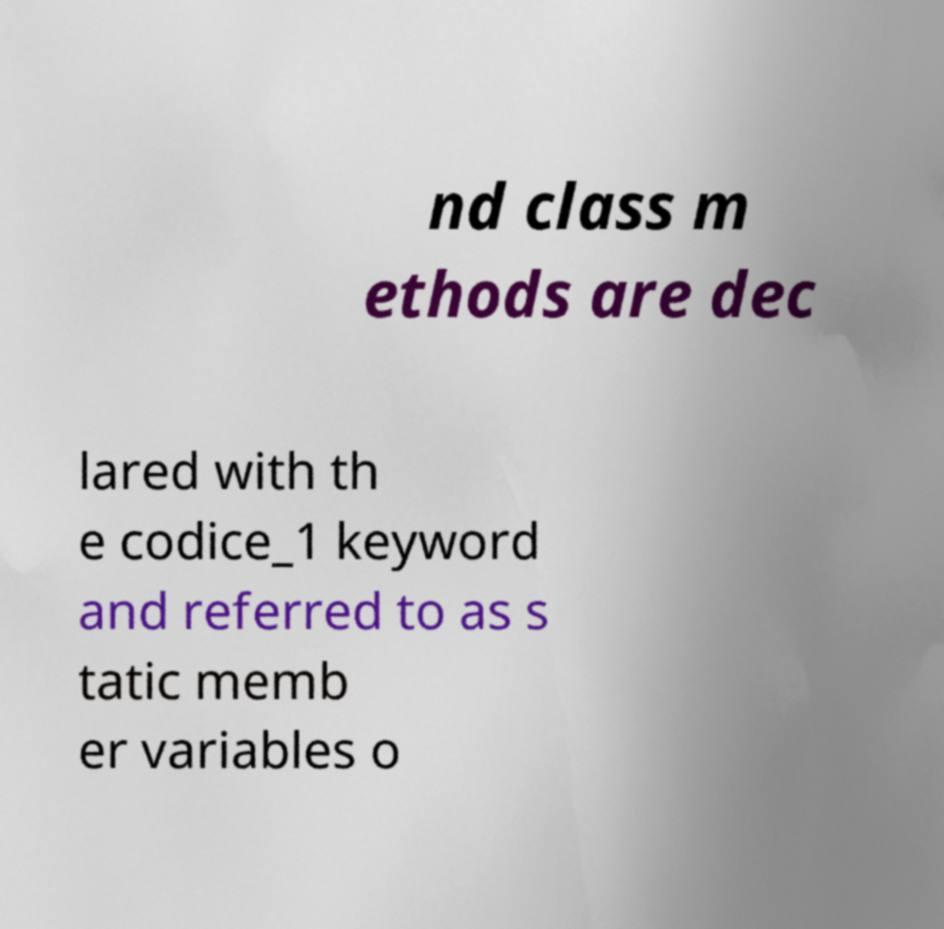Please identify and transcribe the text found in this image. nd class m ethods are dec lared with th e codice_1 keyword and referred to as s tatic memb er variables o 